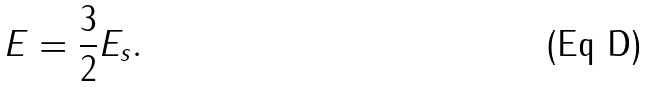<formula> <loc_0><loc_0><loc_500><loc_500>E = \frac { 3 } { 2 } E _ { s } .</formula> 